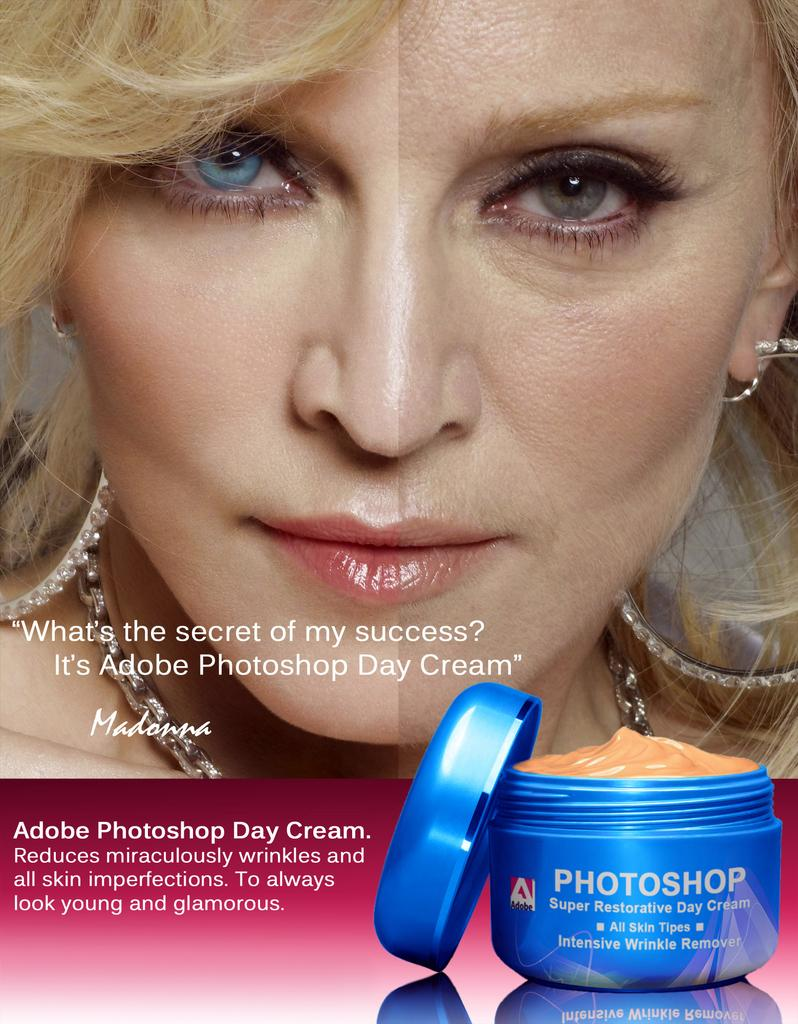Provide a one-sentence caption for the provided image. Madonna poses for an ad for Adobe Photoshop Day Cream. 